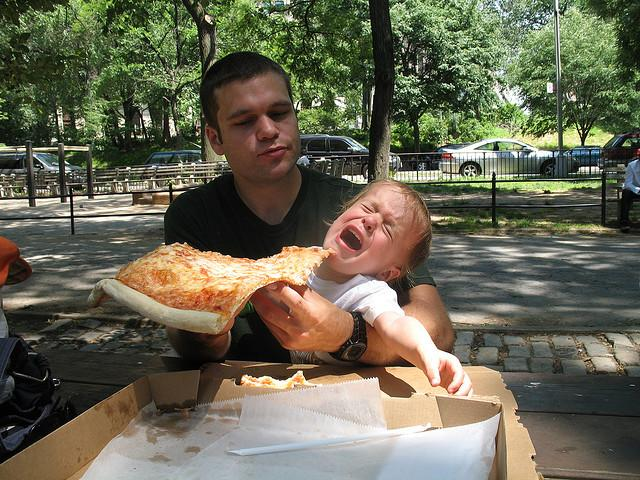What is the most popular pizza cheese?

Choices:
A) cheddar
B) mozzarella
C) gouda
D) american mozzarella 